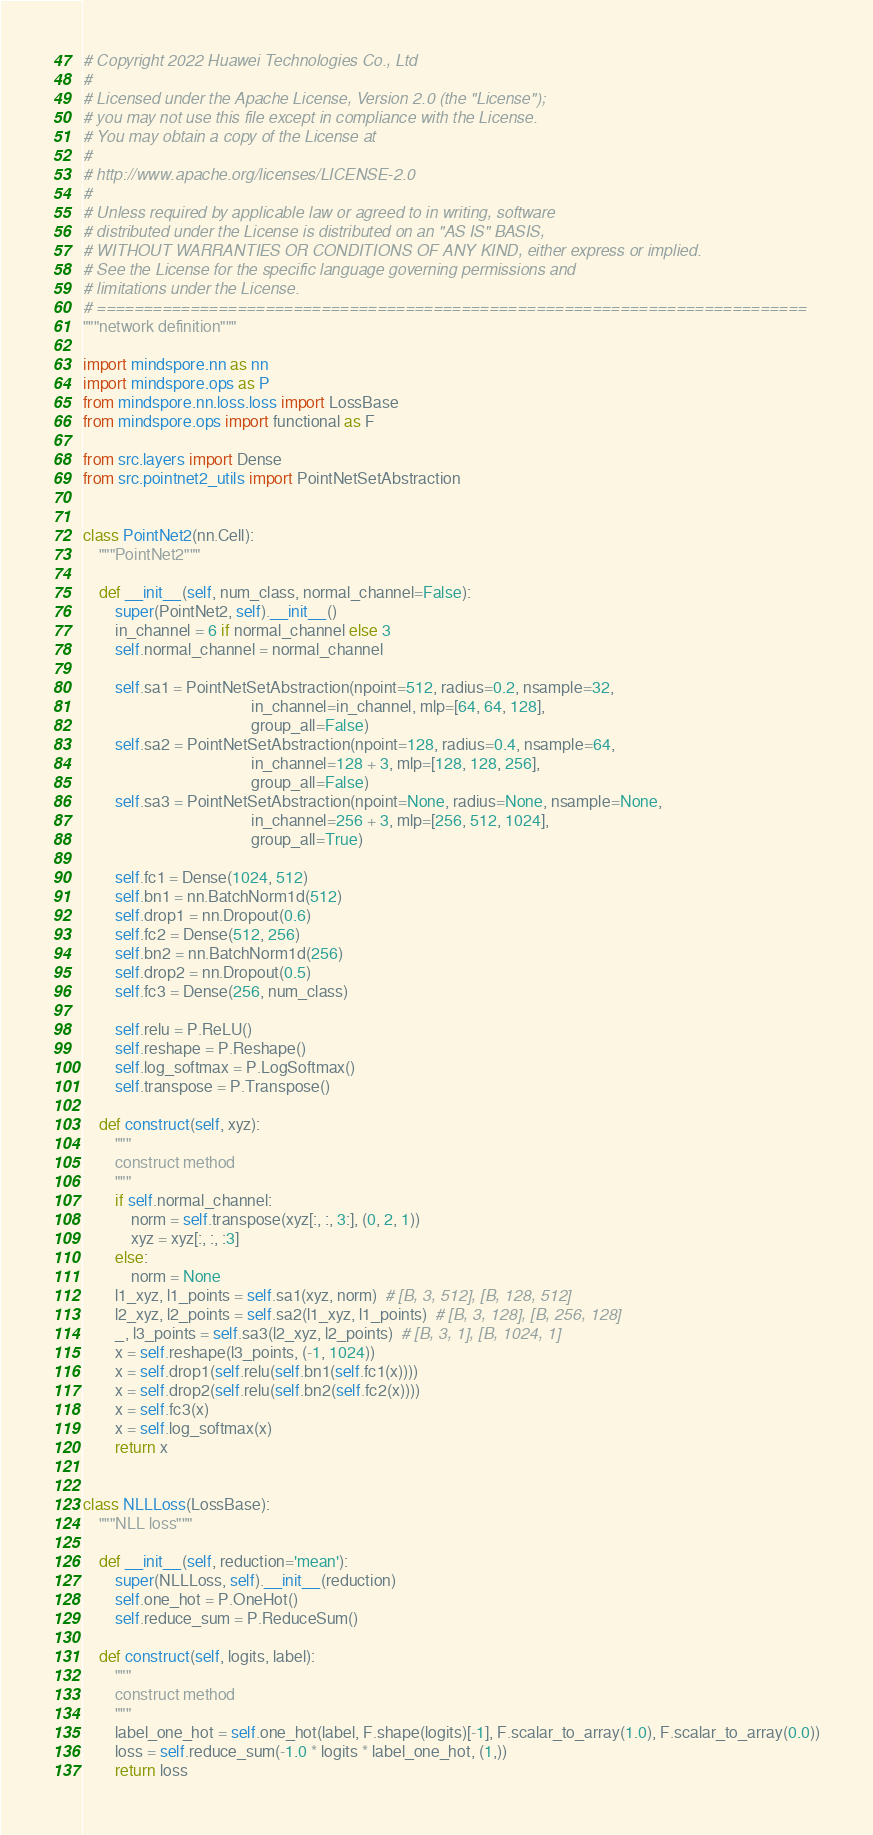Convert code to text. <code><loc_0><loc_0><loc_500><loc_500><_Python_># Copyright 2022 Huawei Technologies Co., Ltd
#
# Licensed under the Apache License, Version 2.0 (the "License");
# you may not use this file except in compliance with the License.
# You may obtain a copy of the License at
#
# http://www.apache.org/licenses/LICENSE-2.0
#
# Unless required by applicable law or agreed to in writing, software
# distributed under the License is distributed on an "AS IS" BASIS,
# WITHOUT WARRANTIES OR CONDITIONS OF ANY KIND, either express or implied.
# See the License for the specific language governing permissions and
# limitations under the License.
# ============================================================================
"""network definition"""

import mindspore.nn as nn
import mindspore.ops as P
from mindspore.nn.loss.loss import LossBase
from mindspore.ops import functional as F

from src.layers import Dense
from src.pointnet2_utils import PointNetSetAbstraction


class PointNet2(nn.Cell):
    """PointNet2"""

    def __init__(self, num_class, normal_channel=False):
        super(PointNet2, self).__init__()
        in_channel = 6 if normal_channel else 3
        self.normal_channel = normal_channel

        self.sa1 = PointNetSetAbstraction(npoint=512, radius=0.2, nsample=32,
                                          in_channel=in_channel, mlp=[64, 64, 128],
                                          group_all=False)
        self.sa2 = PointNetSetAbstraction(npoint=128, radius=0.4, nsample=64,
                                          in_channel=128 + 3, mlp=[128, 128, 256],
                                          group_all=False)
        self.sa3 = PointNetSetAbstraction(npoint=None, radius=None, nsample=None,
                                          in_channel=256 + 3, mlp=[256, 512, 1024],
                                          group_all=True)

        self.fc1 = Dense(1024, 512)
        self.bn1 = nn.BatchNorm1d(512)
        self.drop1 = nn.Dropout(0.6)
        self.fc2 = Dense(512, 256)
        self.bn2 = nn.BatchNorm1d(256)
        self.drop2 = nn.Dropout(0.5)
        self.fc3 = Dense(256, num_class)

        self.relu = P.ReLU()
        self.reshape = P.Reshape()
        self.log_softmax = P.LogSoftmax()
        self.transpose = P.Transpose()

    def construct(self, xyz):
        """
        construct method
        """
        if self.normal_channel:
            norm = self.transpose(xyz[:, :, 3:], (0, 2, 1))
            xyz = xyz[:, :, :3]
        else:
            norm = None
        l1_xyz, l1_points = self.sa1(xyz, norm)  # [B, 3, 512], [B, 128, 512]
        l2_xyz, l2_points = self.sa2(l1_xyz, l1_points)  # [B, 3, 128], [B, 256, 128]
        _, l3_points = self.sa3(l2_xyz, l2_points)  # [B, 3, 1], [B, 1024, 1]
        x = self.reshape(l3_points, (-1, 1024))
        x = self.drop1(self.relu(self.bn1(self.fc1(x))))
        x = self.drop2(self.relu(self.bn2(self.fc2(x))))
        x = self.fc3(x)
        x = self.log_softmax(x)
        return x


class NLLLoss(LossBase):
    """NLL loss"""

    def __init__(self, reduction='mean'):
        super(NLLLoss, self).__init__(reduction)
        self.one_hot = P.OneHot()
        self.reduce_sum = P.ReduceSum()

    def construct(self, logits, label):
        """
        construct method
        """
        label_one_hot = self.one_hot(label, F.shape(logits)[-1], F.scalar_to_array(1.0), F.scalar_to_array(0.0))
        loss = self.reduce_sum(-1.0 * logits * label_one_hot, (1,))
        return loss
</code> 